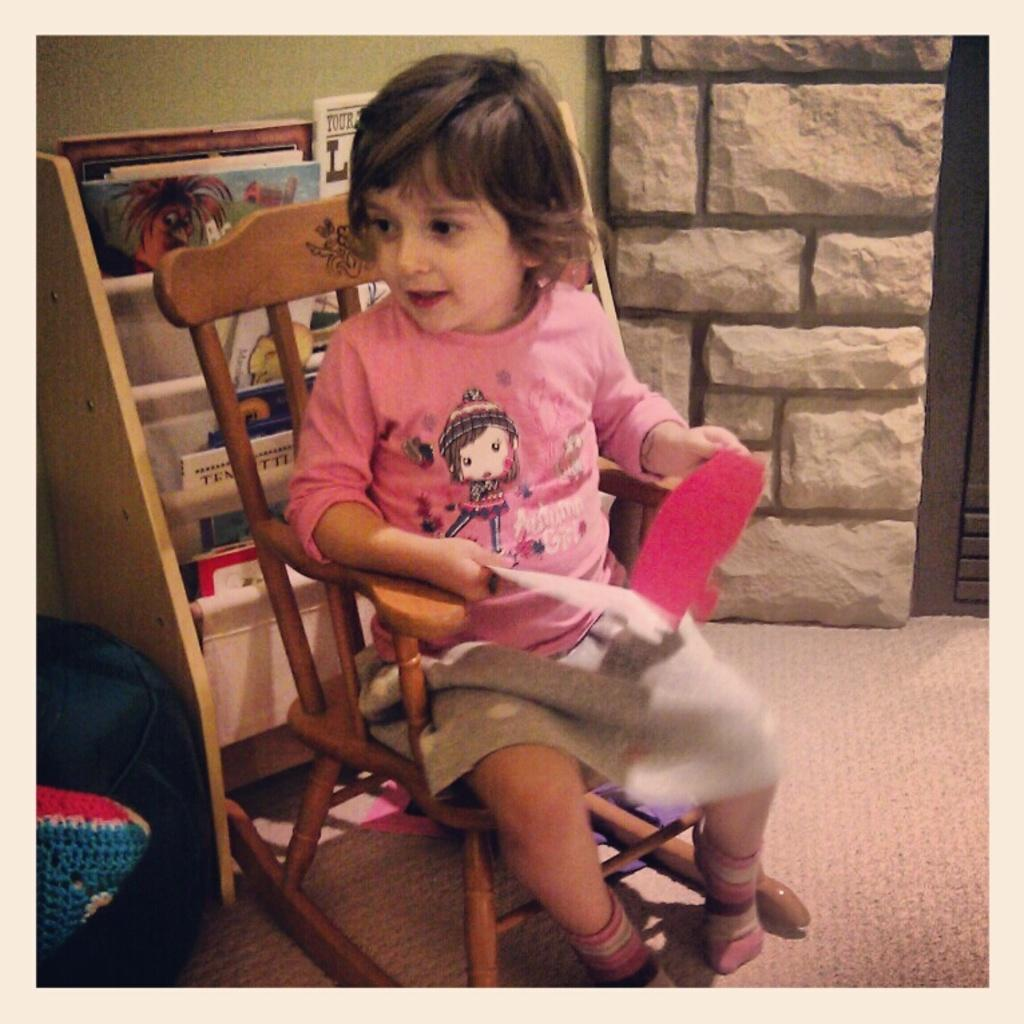What is the main subject of the image? There is a person sitting on a chair in the image. Where is the chair located in the image? The chair is in the center of the image. What can be seen in the background of the image? There is a wall and a shelf in the background of the image. What is on the shelf? The shelf is full of books, and there is a backpack on the shelf. What hobbies does the person sitting on the chair enjoy talking about with their friends? The image does not provide information about the person's hobbies or conversations with friends, so we cannot answer this question. 